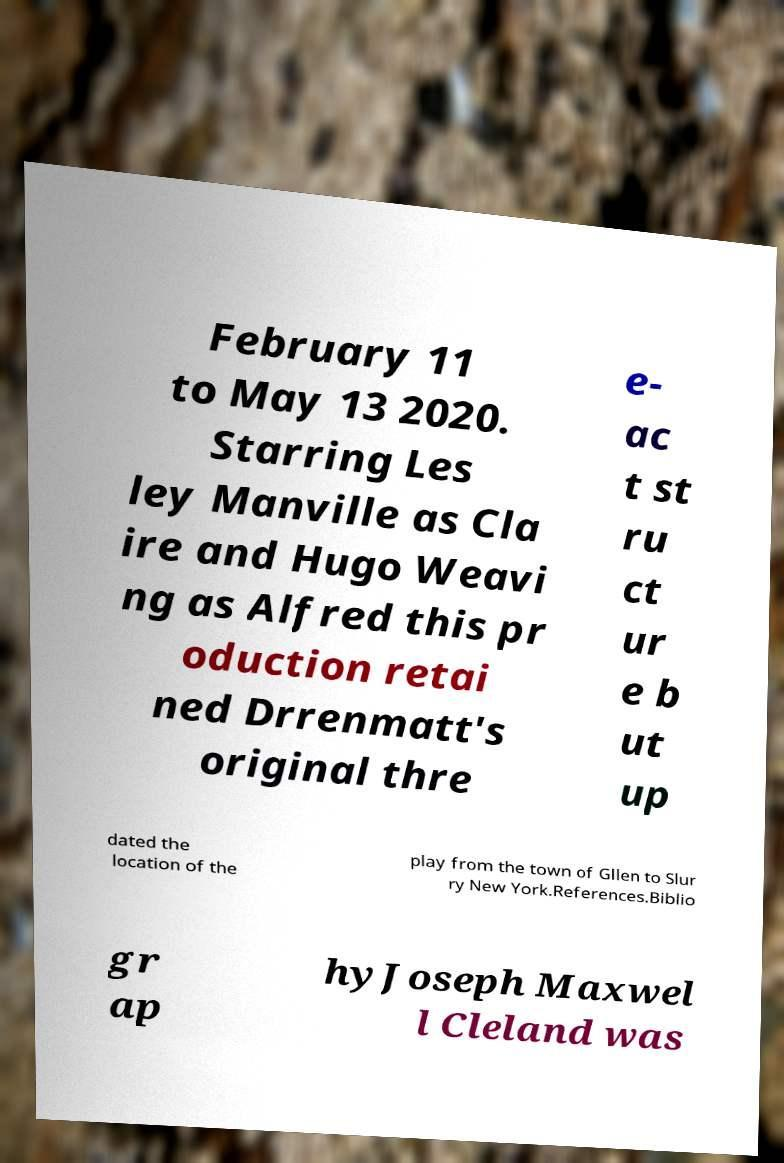I need the written content from this picture converted into text. Can you do that? February 11 to May 13 2020. Starring Les ley Manville as Cla ire and Hugo Weavi ng as Alfred this pr oduction retai ned Drrenmatt's original thre e- ac t st ru ct ur e b ut up dated the location of the play from the town of Gllen to Slur ry New York.References.Biblio gr ap hyJoseph Maxwel l Cleland was 